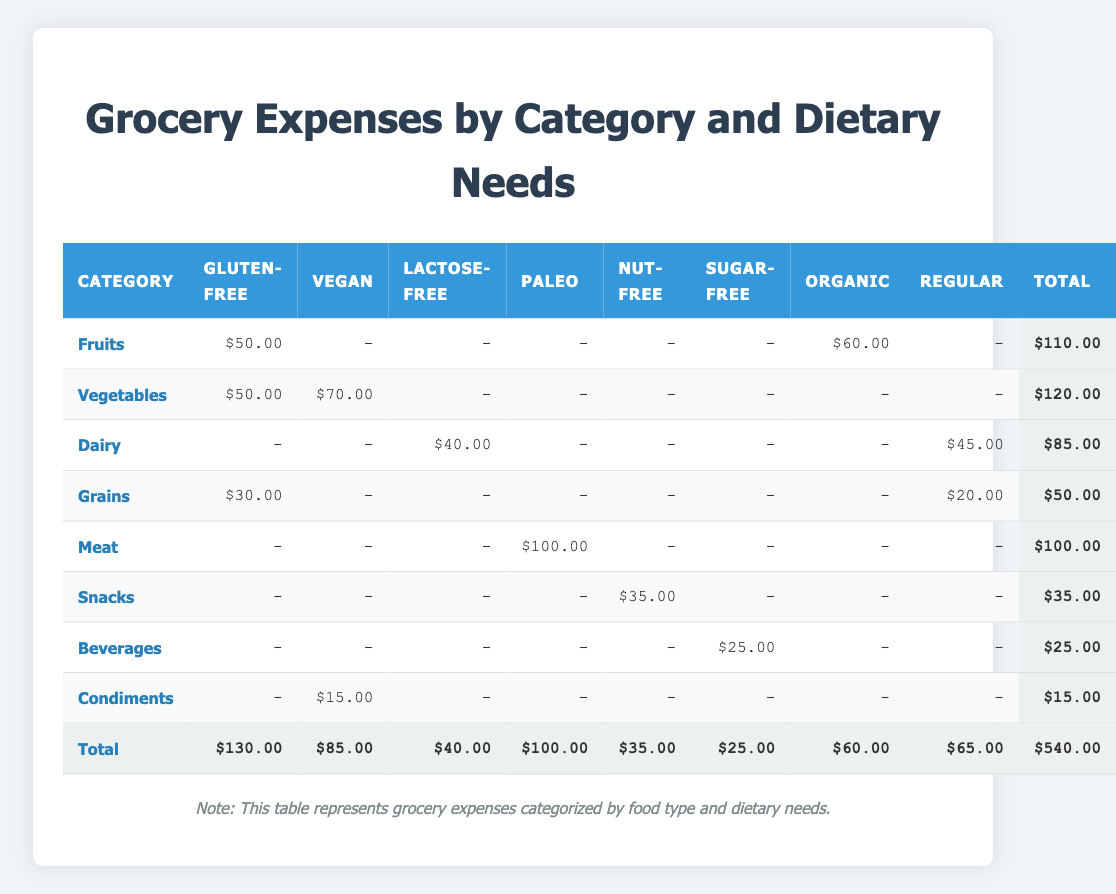What is the total grocery expense for the Vegan category? The expense listed under the Vegan category across the rows is $70.00 (Vegetables) + $15.00 (Condiments) = $85.00.
Answer: 85.00 Which category has the highest total expense? To find the highest total expense, the total for each category needs to be compared. The total expenses are Fruits: $110.00, Vegetables: $120.00, Dairy: $85.00, Grains: $50.00, Meat: $100.00, Snacks: $35.00, Beverages: $25.00, and Condiments: $15.00. The highest total is Vegetables at $120.00.
Answer: Vegetables Is there any expense recorded for the Nut-Free diet in the Dairy category? In the Dairy category, only Lactose-Free ($40.00) and Regular ($45.00) expenses are recorded. There is no expense recorded for Nut-Free.
Answer: No What is the total expense for Gluten-Free items? The total expense for Gluten-Free items can be found by summing the respective values: Fruits: $50.00 + Vegetables: $50.00 + Grains: $30.00 = $130.00.
Answer: 130.00 Are there any categories that do not have expenses for the Sugar-Free dietary need? Examining the Sugar-Free expenses reveals that Fruits, Vegetables, Dairy, Grains, Meat, Snacks, and Condiments all do not have Sugar-Free expenses, except Beverages which has an expense of $25.00. Therefore, there are several categories without Sugar-Free expenses.
Answer: Yes What is the average expense for the Organic items? The only item listed under Organic is Fruits, which has an expense of $60.00. Since there is only one value, the average is the same as this value.
Answer: 60.00 How much is spent on Snacks compared to the total spending on all dietary needs? The total spending on Snacks is $35.00, while the total spending calculated from the last row of the table is $540.00. The proportion spent on Snacks is 35.00 / 540.00 which gives a percentage of approximately 6.48%.
Answer: 6.48% Which dietary need has the lowest total expenditure? The total for each dietary need is calculated as follows: Gluten-Free: $130.00, Vegan: $85.00, Lactose-Free: $40.00, Paleo: $100.00, Nut-Free: $35.00, Sugar-Free: $25.00, Organic: $60.00, Regular: $65.00. The lowest among these is Sugar-Free at $25.00.
Answer: Sugar-Free Are any expenses recorded for the Regular dietary need in both Dairy and Grains categories? Yes, there is an expense of $45.00 for Regular in the Dairy category and $20.00 for Regular in the Grains category, indicating expenses are indeed recorded for both.
Answer: Yes 